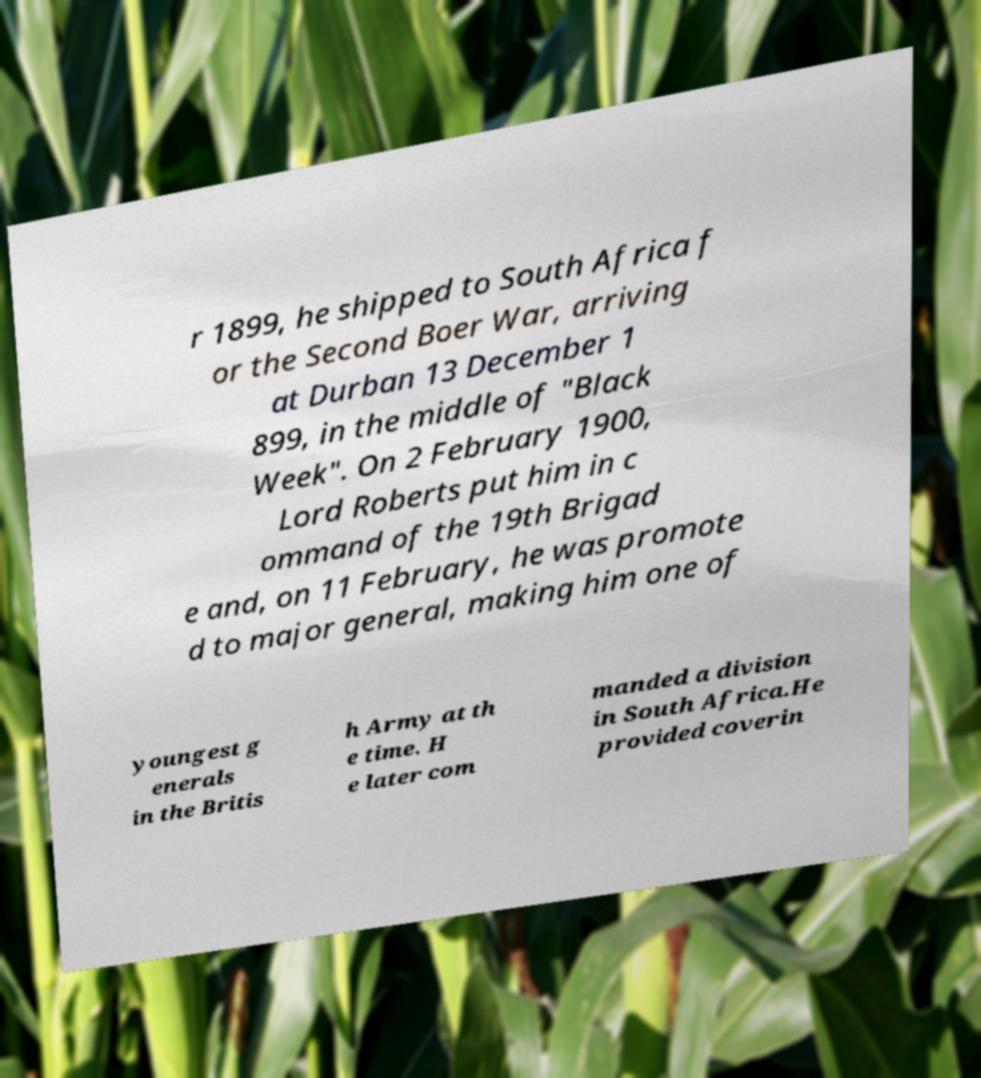Please read and relay the text visible in this image. What does it say? r 1899, he shipped to South Africa f or the Second Boer War, arriving at Durban 13 December 1 899, in the middle of "Black Week". On 2 February 1900, Lord Roberts put him in c ommand of the 19th Brigad e and, on 11 February, he was promote d to major general, making him one of youngest g enerals in the Britis h Army at th e time. H e later com manded a division in South Africa.He provided coverin 